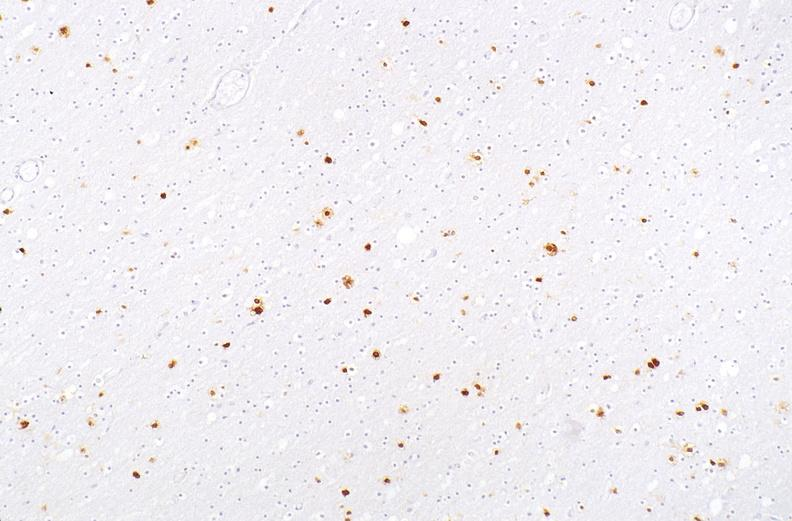what is present?
Answer the question using a single word or phrase. Nervous 